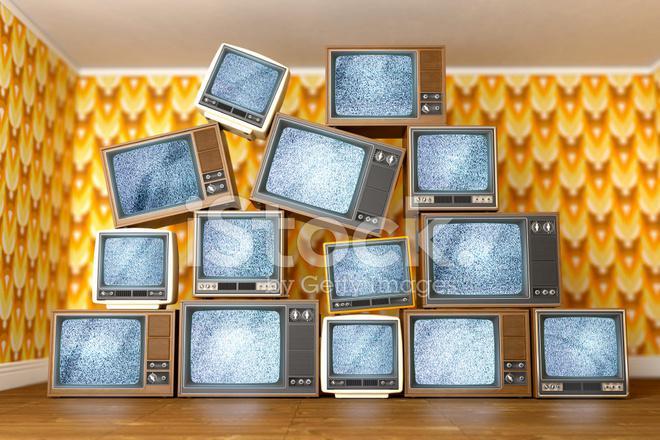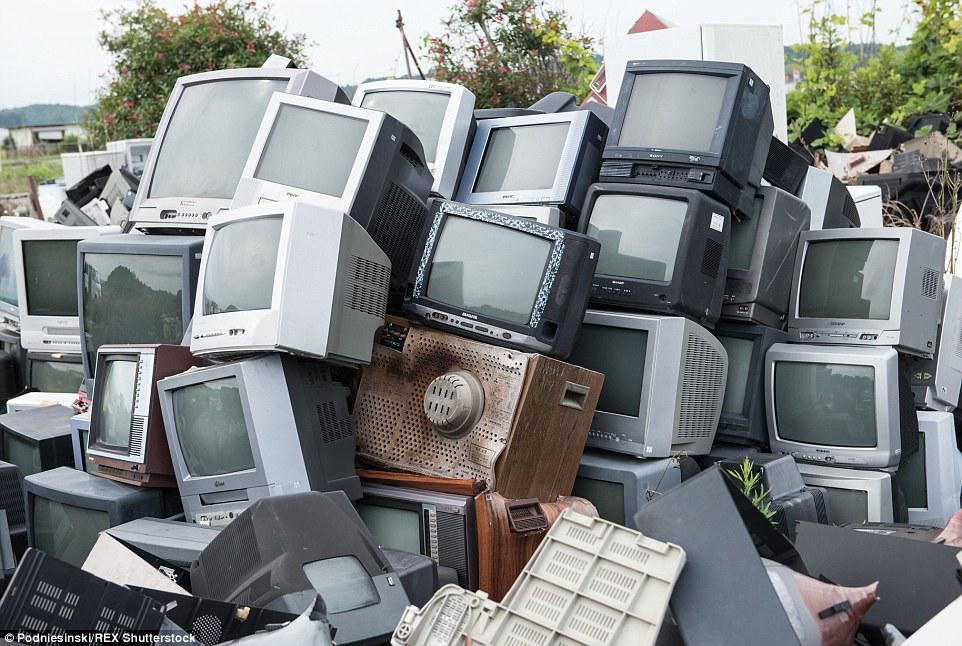The first image is the image on the left, the second image is the image on the right. Assess this claim about the two images: "An image shows TV-type appliances piled in a room in front of pattered wallpaper.". Correct or not? Answer yes or no. Yes. 